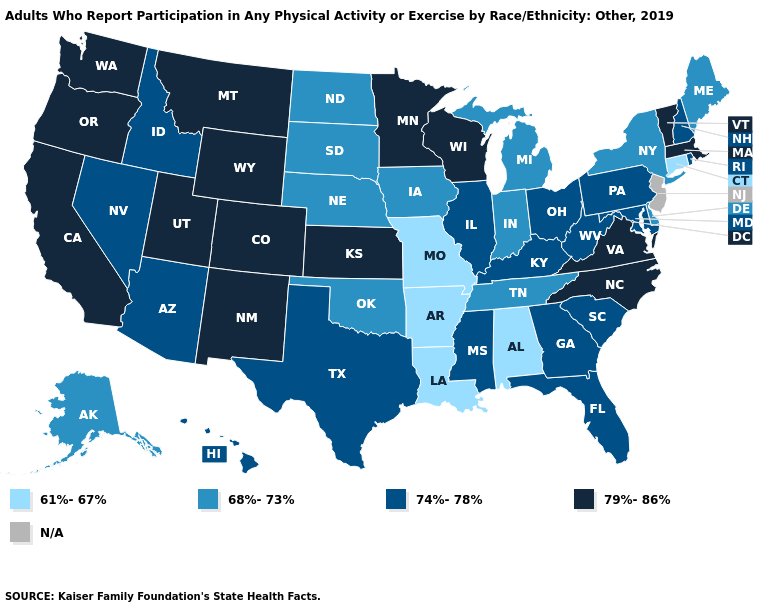Among the states that border West Virginia , which have the lowest value?
Give a very brief answer. Kentucky, Maryland, Ohio, Pennsylvania. What is the lowest value in the West?
Keep it brief. 68%-73%. Among the states that border Missouri , does Kansas have the highest value?
Keep it brief. Yes. Does New York have the highest value in the USA?
Be succinct. No. What is the value of Colorado?
Concise answer only. 79%-86%. Does the first symbol in the legend represent the smallest category?
Quick response, please. Yes. Name the states that have a value in the range 74%-78%?
Be succinct. Arizona, Florida, Georgia, Hawaii, Idaho, Illinois, Kentucky, Maryland, Mississippi, Nevada, New Hampshire, Ohio, Pennsylvania, Rhode Island, South Carolina, Texas, West Virginia. Name the states that have a value in the range 61%-67%?
Answer briefly. Alabama, Arkansas, Connecticut, Louisiana, Missouri. Which states have the highest value in the USA?
Answer briefly. California, Colorado, Kansas, Massachusetts, Minnesota, Montana, New Mexico, North Carolina, Oregon, Utah, Vermont, Virginia, Washington, Wisconsin, Wyoming. Among the states that border Alabama , which have the highest value?
Write a very short answer. Florida, Georgia, Mississippi. What is the value of Missouri?
Short answer required. 61%-67%. What is the value of Wyoming?
Quick response, please. 79%-86%. What is the value of Georgia?
Quick response, please. 74%-78%. Name the states that have a value in the range 61%-67%?
Short answer required. Alabama, Arkansas, Connecticut, Louisiana, Missouri. 